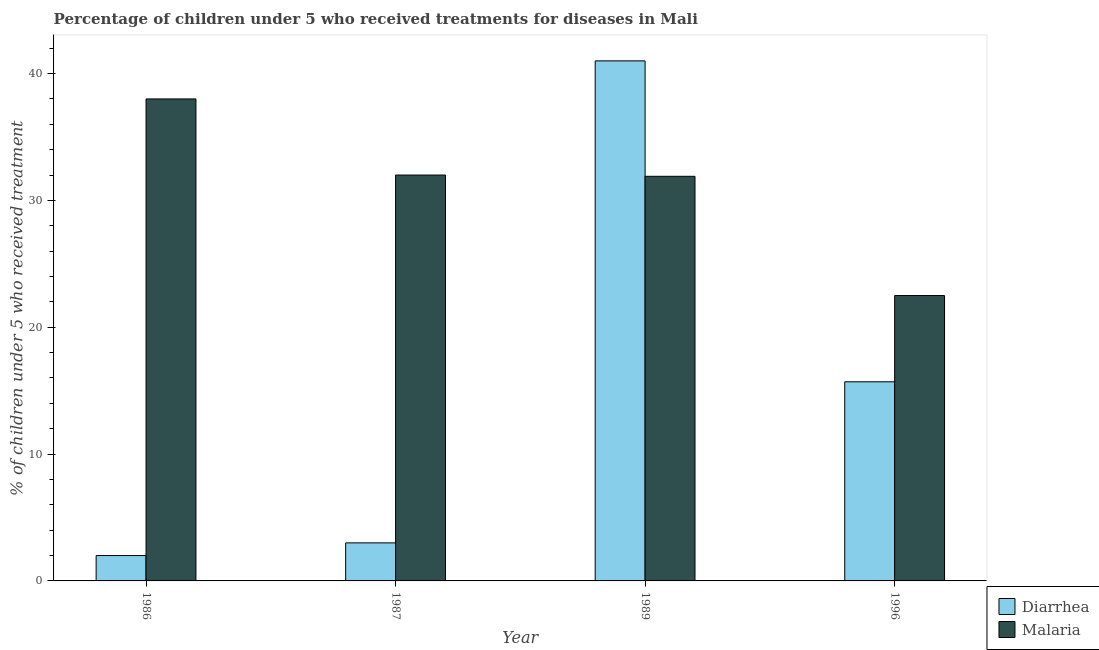How many different coloured bars are there?
Keep it short and to the point. 2. How many bars are there on the 4th tick from the left?
Provide a succinct answer. 2. How many bars are there on the 1st tick from the right?
Keep it short and to the point. 2. What is the label of the 1st group of bars from the left?
Ensure brevity in your answer.  1986. In how many cases, is the number of bars for a given year not equal to the number of legend labels?
Give a very brief answer. 0. What is the percentage of children who received treatment for malaria in 1987?
Your answer should be compact. 32. Across all years, what is the minimum percentage of children who received treatment for diarrhoea?
Keep it short and to the point. 2. In which year was the percentage of children who received treatment for diarrhoea maximum?
Offer a very short reply. 1989. What is the total percentage of children who received treatment for malaria in the graph?
Offer a terse response. 124.4. What is the difference between the percentage of children who received treatment for diarrhoea in 1986 and that in 1989?
Your answer should be very brief. -39. What is the difference between the percentage of children who received treatment for diarrhoea in 1996 and the percentage of children who received treatment for malaria in 1989?
Ensure brevity in your answer.  -25.3. What is the average percentage of children who received treatment for diarrhoea per year?
Your response must be concise. 15.43. In the year 1989, what is the difference between the percentage of children who received treatment for diarrhoea and percentage of children who received treatment for malaria?
Give a very brief answer. 0. What is the ratio of the percentage of children who received treatment for diarrhoea in 1989 to that in 1996?
Offer a very short reply. 2.61. Is the difference between the percentage of children who received treatment for diarrhoea in 1989 and 1996 greater than the difference between the percentage of children who received treatment for malaria in 1989 and 1996?
Make the answer very short. No. What is the difference between the highest and the second highest percentage of children who received treatment for diarrhoea?
Provide a short and direct response. 25.3. What is the difference between the highest and the lowest percentage of children who received treatment for malaria?
Your answer should be compact. 15.5. Is the sum of the percentage of children who received treatment for malaria in 1986 and 1996 greater than the maximum percentage of children who received treatment for diarrhoea across all years?
Ensure brevity in your answer.  Yes. What does the 1st bar from the left in 1996 represents?
Your response must be concise. Diarrhea. What does the 2nd bar from the right in 1989 represents?
Give a very brief answer. Diarrhea. Are all the bars in the graph horizontal?
Give a very brief answer. No. How many years are there in the graph?
Provide a succinct answer. 4. Are the values on the major ticks of Y-axis written in scientific E-notation?
Provide a succinct answer. No. Does the graph contain any zero values?
Provide a short and direct response. No. How many legend labels are there?
Provide a short and direct response. 2. What is the title of the graph?
Provide a short and direct response. Percentage of children under 5 who received treatments for diseases in Mali. Does "Urban agglomerations" appear as one of the legend labels in the graph?
Your answer should be compact. No. What is the label or title of the X-axis?
Give a very brief answer. Year. What is the label or title of the Y-axis?
Make the answer very short. % of children under 5 who received treatment. What is the % of children under 5 who received treatment in Malaria in 1986?
Provide a succinct answer. 38. What is the % of children under 5 who received treatment in Diarrhea in 1987?
Offer a very short reply. 3. What is the % of children under 5 who received treatment of Malaria in 1989?
Your response must be concise. 31.9. What is the % of children under 5 who received treatment of Diarrhea in 1996?
Offer a terse response. 15.7. What is the % of children under 5 who received treatment of Malaria in 1996?
Offer a very short reply. 22.5. Across all years, what is the maximum % of children under 5 who received treatment of Malaria?
Your response must be concise. 38. Across all years, what is the minimum % of children under 5 who received treatment of Malaria?
Keep it short and to the point. 22.5. What is the total % of children under 5 who received treatment of Diarrhea in the graph?
Provide a short and direct response. 61.7. What is the total % of children under 5 who received treatment in Malaria in the graph?
Keep it short and to the point. 124.4. What is the difference between the % of children under 5 who received treatment in Diarrhea in 1986 and that in 1989?
Make the answer very short. -39. What is the difference between the % of children under 5 who received treatment in Diarrhea in 1986 and that in 1996?
Make the answer very short. -13.7. What is the difference between the % of children under 5 who received treatment in Malaria in 1986 and that in 1996?
Make the answer very short. 15.5. What is the difference between the % of children under 5 who received treatment in Diarrhea in 1987 and that in 1989?
Provide a succinct answer. -38. What is the difference between the % of children under 5 who received treatment of Malaria in 1987 and that in 1989?
Ensure brevity in your answer.  0.1. What is the difference between the % of children under 5 who received treatment in Diarrhea in 1987 and that in 1996?
Your answer should be compact. -12.7. What is the difference between the % of children under 5 who received treatment in Diarrhea in 1989 and that in 1996?
Your answer should be very brief. 25.3. What is the difference between the % of children under 5 who received treatment of Diarrhea in 1986 and the % of children under 5 who received treatment of Malaria in 1987?
Your answer should be very brief. -30. What is the difference between the % of children under 5 who received treatment of Diarrhea in 1986 and the % of children under 5 who received treatment of Malaria in 1989?
Provide a short and direct response. -29.9. What is the difference between the % of children under 5 who received treatment in Diarrhea in 1986 and the % of children under 5 who received treatment in Malaria in 1996?
Make the answer very short. -20.5. What is the difference between the % of children under 5 who received treatment of Diarrhea in 1987 and the % of children under 5 who received treatment of Malaria in 1989?
Your response must be concise. -28.9. What is the difference between the % of children under 5 who received treatment of Diarrhea in 1987 and the % of children under 5 who received treatment of Malaria in 1996?
Your answer should be very brief. -19.5. What is the difference between the % of children under 5 who received treatment in Diarrhea in 1989 and the % of children under 5 who received treatment in Malaria in 1996?
Your answer should be compact. 18.5. What is the average % of children under 5 who received treatment of Diarrhea per year?
Make the answer very short. 15.43. What is the average % of children under 5 who received treatment in Malaria per year?
Your answer should be compact. 31.1. In the year 1986, what is the difference between the % of children under 5 who received treatment in Diarrhea and % of children under 5 who received treatment in Malaria?
Offer a terse response. -36. In the year 1989, what is the difference between the % of children under 5 who received treatment in Diarrhea and % of children under 5 who received treatment in Malaria?
Offer a terse response. 9.1. In the year 1996, what is the difference between the % of children under 5 who received treatment in Diarrhea and % of children under 5 who received treatment in Malaria?
Your response must be concise. -6.8. What is the ratio of the % of children under 5 who received treatment in Malaria in 1986 to that in 1987?
Your answer should be very brief. 1.19. What is the ratio of the % of children under 5 who received treatment of Diarrhea in 1986 to that in 1989?
Make the answer very short. 0.05. What is the ratio of the % of children under 5 who received treatment in Malaria in 1986 to that in 1989?
Offer a very short reply. 1.19. What is the ratio of the % of children under 5 who received treatment in Diarrhea in 1986 to that in 1996?
Give a very brief answer. 0.13. What is the ratio of the % of children under 5 who received treatment in Malaria in 1986 to that in 1996?
Your answer should be compact. 1.69. What is the ratio of the % of children under 5 who received treatment of Diarrhea in 1987 to that in 1989?
Make the answer very short. 0.07. What is the ratio of the % of children under 5 who received treatment of Diarrhea in 1987 to that in 1996?
Give a very brief answer. 0.19. What is the ratio of the % of children under 5 who received treatment of Malaria in 1987 to that in 1996?
Provide a succinct answer. 1.42. What is the ratio of the % of children under 5 who received treatment of Diarrhea in 1989 to that in 1996?
Offer a terse response. 2.61. What is the ratio of the % of children under 5 who received treatment in Malaria in 1989 to that in 1996?
Make the answer very short. 1.42. What is the difference between the highest and the second highest % of children under 5 who received treatment of Diarrhea?
Provide a short and direct response. 25.3. What is the difference between the highest and the second highest % of children under 5 who received treatment in Malaria?
Provide a short and direct response. 6. What is the difference between the highest and the lowest % of children under 5 who received treatment of Malaria?
Your answer should be compact. 15.5. 